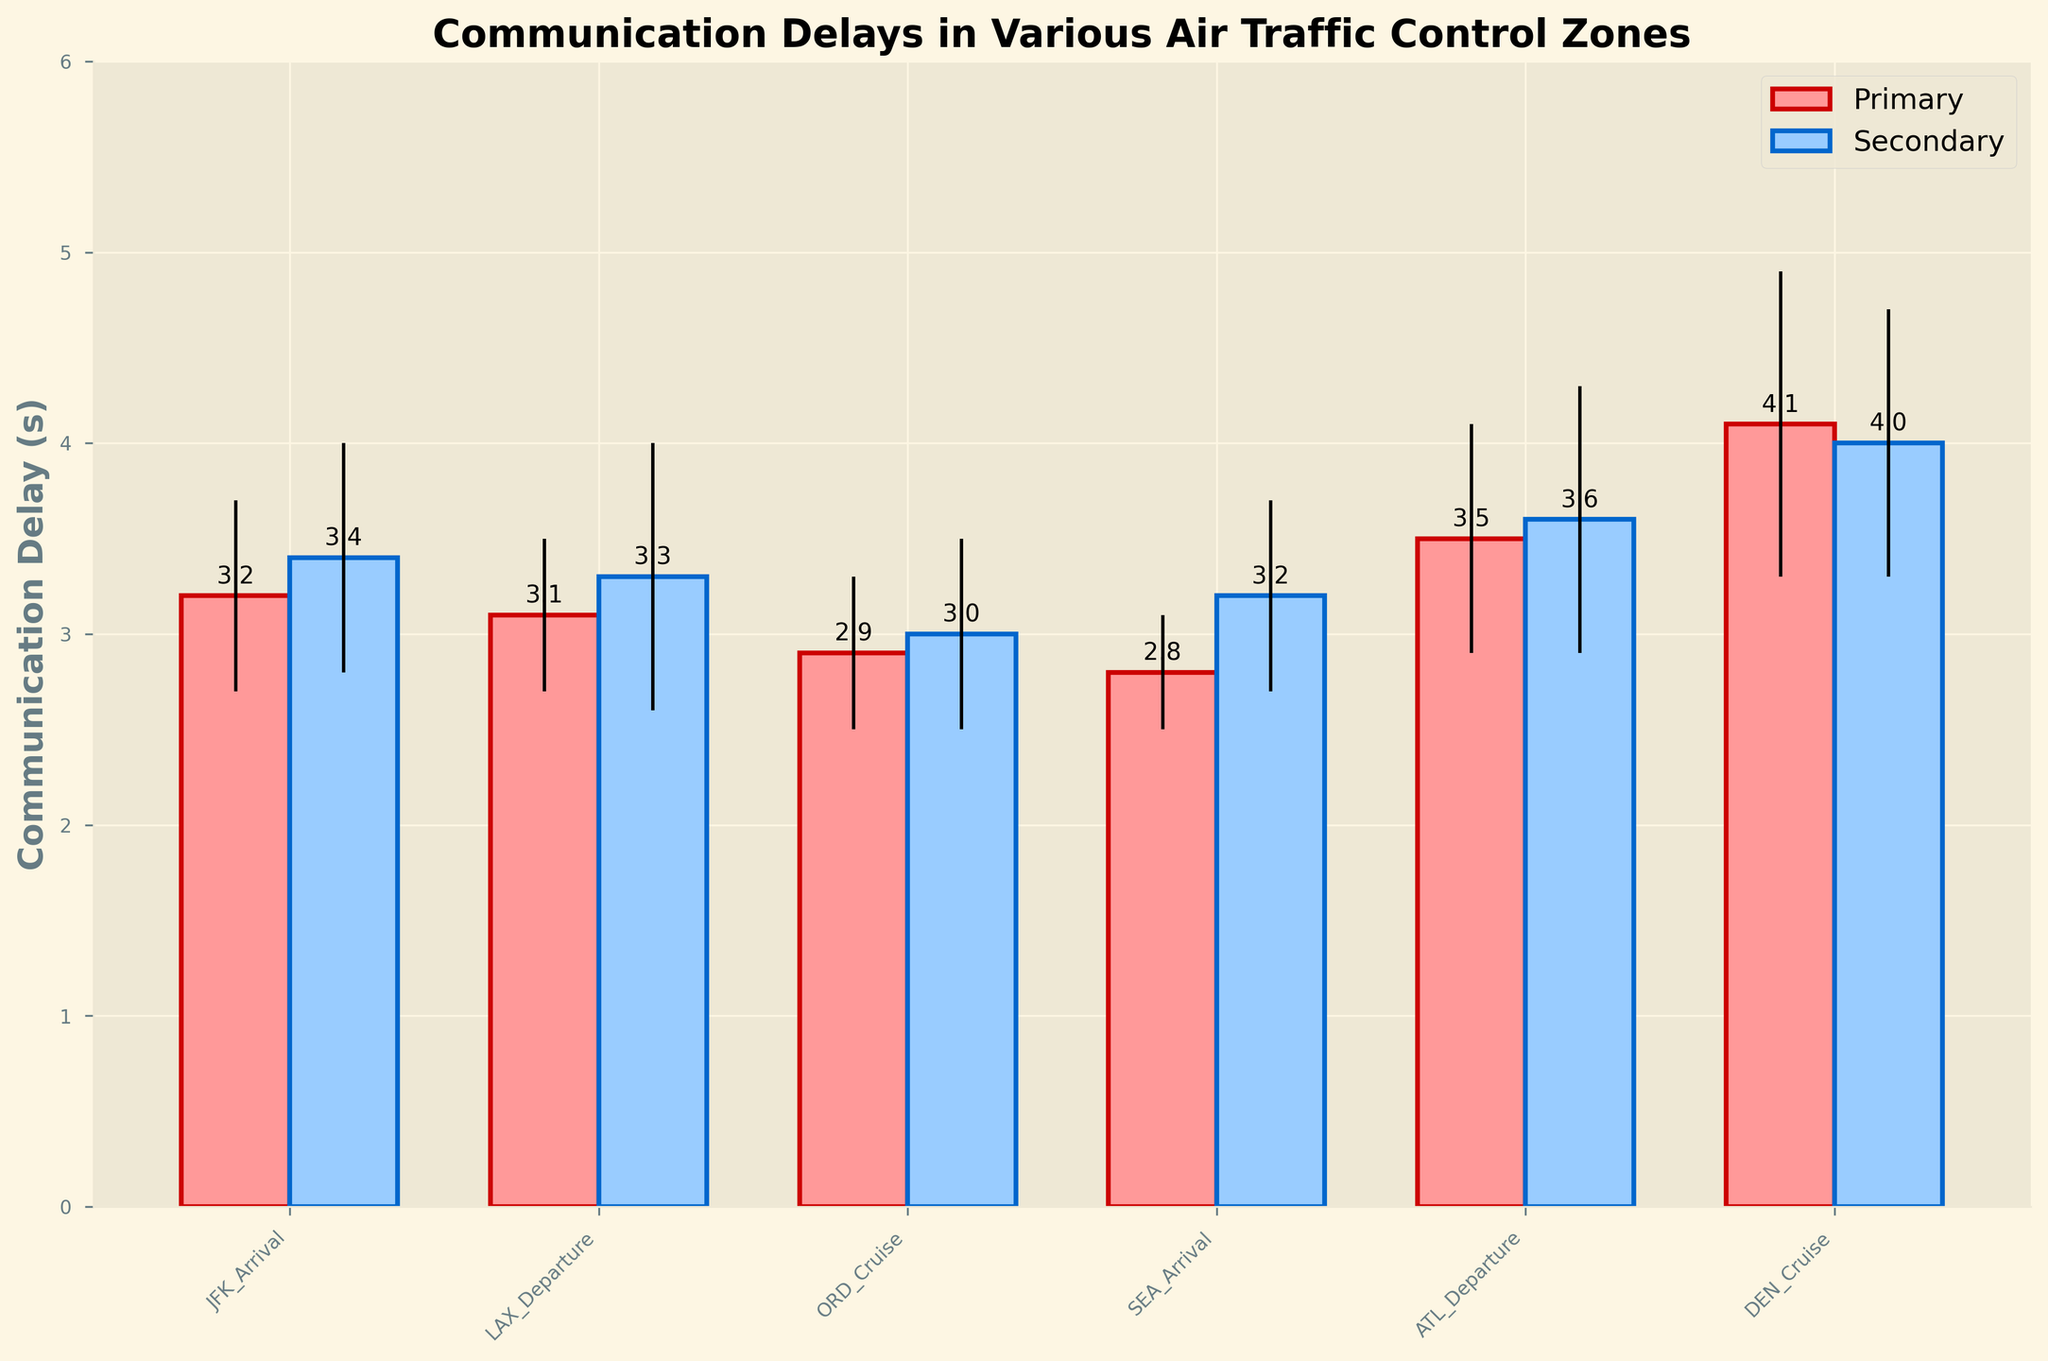What is the title of the plot? The title of the plot is usually located at the top center and provides a summary of the visual information. In this plot, the title is "Communication Delays in Various Air Traffic Control Zones"
Answer: Communication Delays in Various Air Traffic Control Zones What is the maximum communication delay observed? Look at the bar that reaches the highest point along the y-axis. The tallest bar represents the maximum communication delay. The tallest bar corresponds to the Primary observation in the DEN_Cruise zone with a delay of 4.1 seconds.
Answer: 4.1 seconds How many different Air Traffic Control Zones are displayed in the plot? Count the unique tick labels along the x-axis. The zones listed are JFK_Arrival, LAX_Departure, ORD_Cruise, SEA_Arrival, ATL_Departure, and DEN_Cruise. There are a total of 6 zones.
Answer: 6 zones Which Air Traffic Control Zone shows the smallest communication delay for Primary observations? Identify the bar with the smallest height for Primary observations by comparing the pink and red bars. The shortest Primary bar is in the SEA_Arrival zone with a delay of 2.8 seconds.
Answer: SEA_Arrival What is the average communication delay for the ATL_Departure zone? There are two observations for ATL_Departure: Primary with 3.5 seconds and Secondary with 3.6 seconds. Average these values: (3.5 + 3.6) / 2.
Answer: 3.55 seconds Which zones have similar communication delays for both Primary and Secondary observations? Compare the heights of the Primary and Secondary bars within each zone. JFK_Arrival, LAX_Departure, and ORD_Cruise have closely matching delays for both observations.
Answer: JFK_Arrival, LAX_Departure, ORD_Cruise Which observation has a higher communication delay in the SEA_Arrival zone, Primary or Secondary? Compare the height of the bars in the SEA_Arrival zone. The Secondary observation bar is higher with a delay of 3.2 seconds compared to the Primary's 2.8 seconds.
Answer: Secondary What is the difference in communication delay between Primary and Secondary observations in the ORD_Cruise zone? Look at the two bars for ORD_Cruise and subtract the height of the Primary bar (2.9 seconds) from the height of the Secondary bar (3.0 seconds): 3.0 - 2.9 = 0.1 seconds.
Answer: 0.1 seconds How many zones have a standard deviation greater than 0.6 seconds for Secondary observations? Look at the error bars for Secondary (light blue) observations and identify zones where the error bars are larger than 0.6 seconds. These are JFK_Arrival, LAX_Departure, and ATL_Departure (excluding zones with less precise error bars).
Answer: 3 zones Which zone has the largest difference between Primary and Secondary communication delays? Calculate the differences for each zone and find the largest one. The differences are: JFK_Arrival (0.2s), LAX_Departure (0.2s), ORD_Cruise (0.1s), SEA_Arrival (0.4s), ATL_Departure (0.1s), DEN_Cruise (0.1s). The largest difference is in SEA_Arrival with 0.4 seconds.
Answer: SEA_Arrival 